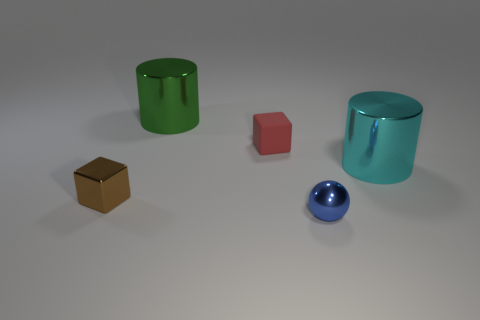Is there any other thing that is made of the same material as the red thing?
Give a very brief answer. No. What is the material of the other small object that is the same shape as the brown metal thing?
Keep it short and to the point. Rubber. How many other red cubes have the same size as the red rubber block?
Keep it short and to the point. 0. What number of cyan objects are either tiny things or tiny spheres?
Give a very brief answer. 0. What is the shape of the shiny object that is behind the large thing that is right of the green metal cylinder?
Keep it short and to the point. Cylinder. The metal thing that is the same size as the brown metal block is what shape?
Your response must be concise. Sphere. Are there the same number of green cylinders that are behind the blue thing and blue metallic objects that are in front of the tiny matte object?
Provide a succinct answer. Yes. There is a red object; is its shape the same as the big thing that is in front of the red matte thing?
Your response must be concise. No. How many other objects are the same material as the red cube?
Keep it short and to the point. 0. Are there any small blue objects in front of the small rubber object?
Provide a short and direct response. Yes. 